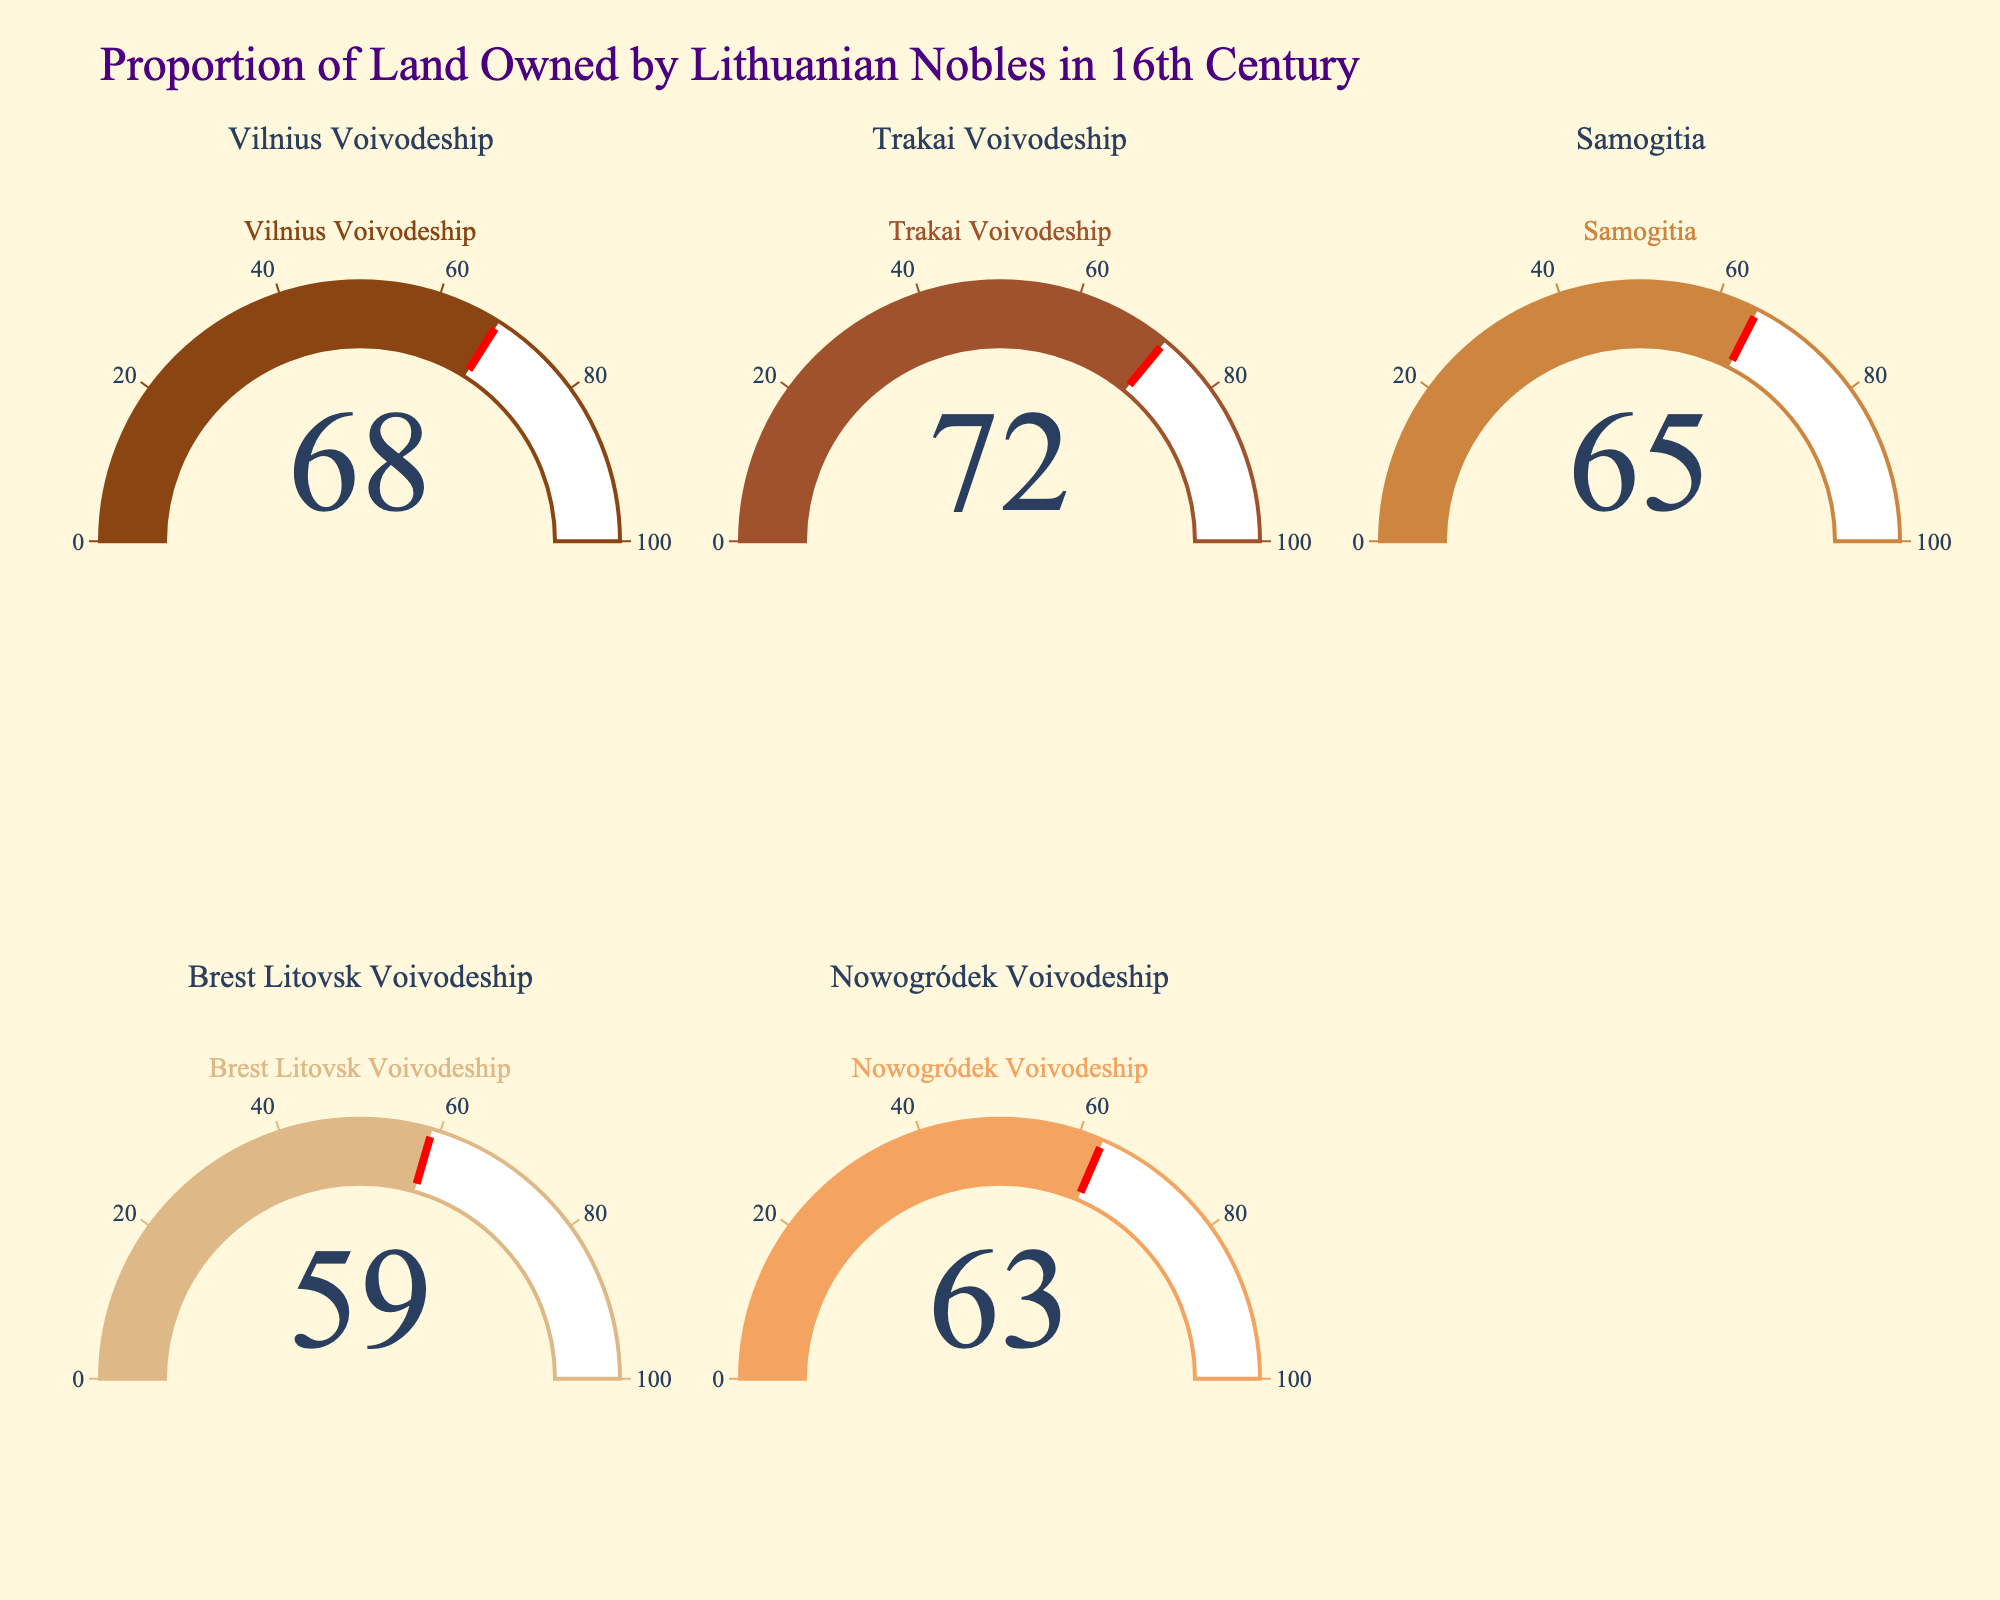What's the title of the figure? The title is displayed at the top of the figure and it indicates the main subject of the visualization, which is the proportion of land owned by Lithuanian nobles in the 16th century.
Answer: Proportion of Land Owned by Lithuanian Nobles in 16th Century How many regions are represented in the figure? Each gauge represents a different region, and there are five gauges in total, each titled with the name of a region.
Answer: 5 Which region has the highest percentage of land ownership by Lithuanian nobles? By comparing the values displayed on each gauge, the highest percentage is found in the Trakai Voivodeship with 72%.
Answer: Trakai Voivodeship What is the combined land ownership percentage of the Vilnius Voivodeship and Samogitia? The figure shows Vilnius Voivodeship with 68% and Samogitia with 65%. Adding these together: 68 + 65 = 133%.
Answer: 133% Which region has the smallest percentage of land ownership by Lithuanian nobles? By comparing all the percentages, the Brest Litovsk Voivodeship has the smallest value at 59%.
Answer: Brest Litovsk Voivodeship What's the average percentage of land owned by Lithuanian nobles across all regions? The percentages are 68, 72, 65, 59, and 63. Summing these: 68 + 72 + 65 + 59 + 63 = 327. Now, divide 327 by 5 to get the average: 327 / 5 = 65.4%.
Answer: 65.4% Which region's land ownership percentage is closest to the average percentage? The calculated average is 65.4%. The regions have percentages of 68, 72, 65, 59, and 63. The closest to 65.4% is 65% (Samogitia).
Answer: Samogitia Is there more than a 10% difference between the region with the highest land ownership and the region with the lowest? The highest percentage is 72% (Trakai Voivodeship), and the lowest is 59% (Brest Litovsk Voivodeship). The difference is 72 - 59 = 13%, which is indeed more than 10%.
Answer: Yes 